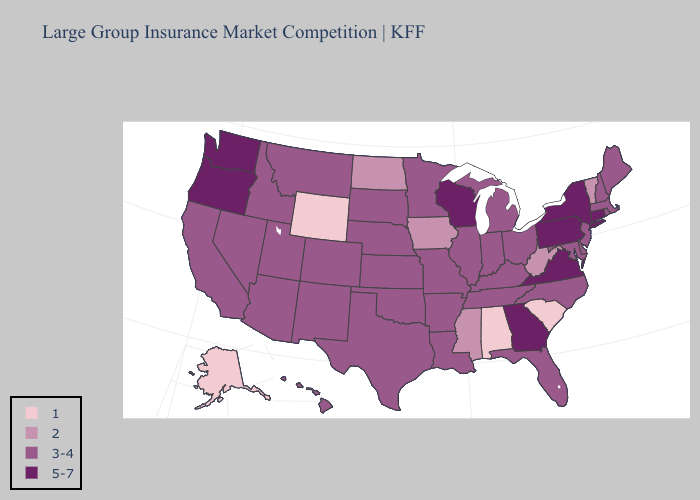Does Wyoming have a higher value than Virginia?
Concise answer only. No. Name the states that have a value in the range 3-4?
Answer briefly. Arizona, Arkansas, California, Colorado, Delaware, Florida, Hawaii, Idaho, Illinois, Indiana, Kansas, Kentucky, Louisiana, Maine, Maryland, Massachusetts, Michigan, Minnesota, Missouri, Montana, Nebraska, Nevada, New Hampshire, New Jersey, New Mexico, North Carolina, Ohio, Oklahoma, Rhode Island, South Dakota, Tennessee, Texas, Utah. Does Tennessee have the highest value in the South?
Short answer required. No. Does the first symbol in the legend represent the smallest category?
Keep it brief. Yes. Does Connecticut have the highest value in the USA?
Be succinct. Yes. What is the highest value in the USA?
Be succinct. 5-7. Does Rhode Island have the highest value in the Northeast?
Give a very brief answer. No. What is the highest value in the MidWest ?
Answer briefly. 5-7. Name the states that have a value in the range 5-7?
Answer briefly. Connecticut, Georgia, New York, Oregon, Pennsylvania, Virginia, Washington, Wisconsin. Name the states that have a value in the range 2?
Concise answer only. Iowa, Mississippi, North Dakota, Vermont, West Virginia. Does Vermont have the lowest value in the Northeast?
Give a very brief answer. Yes. Which states have the lowest value in the West?
Concise answer only. Alaska, Wyoming. What is the lowest value in states that border Mississippi?
Be succinct. 1. What is the lowest value in the USA?
Be succinct. 1. What is the value of Oklahoma?
Keep it brief. 3-4. 